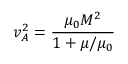Convert formula to latex. <formula><loc_0><loc_0><loc_500><loc_500>v _ { A } ^ { 2 } = \frac { \mu _ { 0 } M ^ { 2 } } { 1 + \mu / \mu _ { 0 } }</formula> 